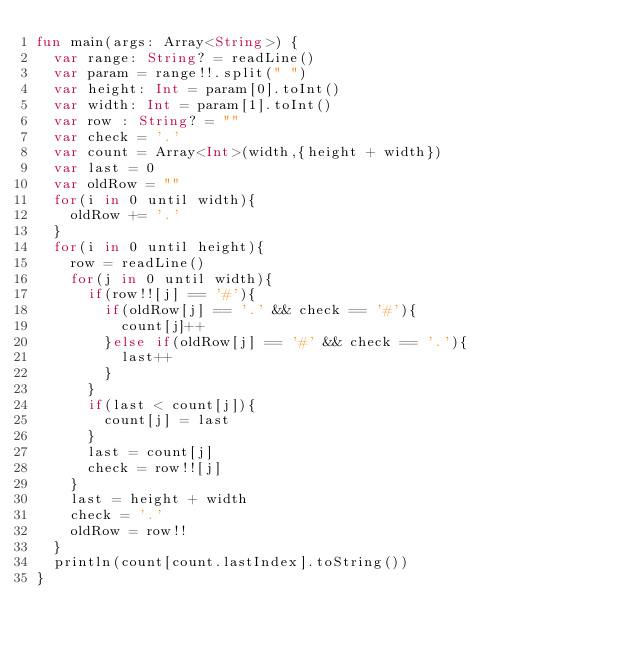<code> <loc_0><loc_0><loc_500><loc_500><_Kotlin_>fun main(args: Array<String>) {
  var range: String? = readLine()
  var param = range!!.split(" ")
  var height: Int = param[0].toInt()
  var width: Int = param[1].toInt()
  var row : String? = ""
  var check = '.'
  var count = Array<Int>(width,{height + width})
  var last = 0
  var oldRow = ""
  for(i in 0 until width){
    oldRow += '.'
  }
  for(i in 0 until height){
    row = readLine()
    for(j in 0 until width){
      if(row!![j] == '#'){
        if(oldRow[j] == '.' && check == '#'){
          count[j]++
        }else if(oldRow[j] == '#' && check == '.'){
          last++
        }
      }
      if(last < count[j]){
        count[j] = last
      }
      last = count[j]
      check = row!![j]
    }
    last = height + width
    check = '.'
    oldRow = row!!
  }
  println(count[count.lastIndex].toString())
}</code> 